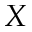Convert formula to latex. <formula><loc_0><loc_0><loc_500><loc_500>X</formula> 